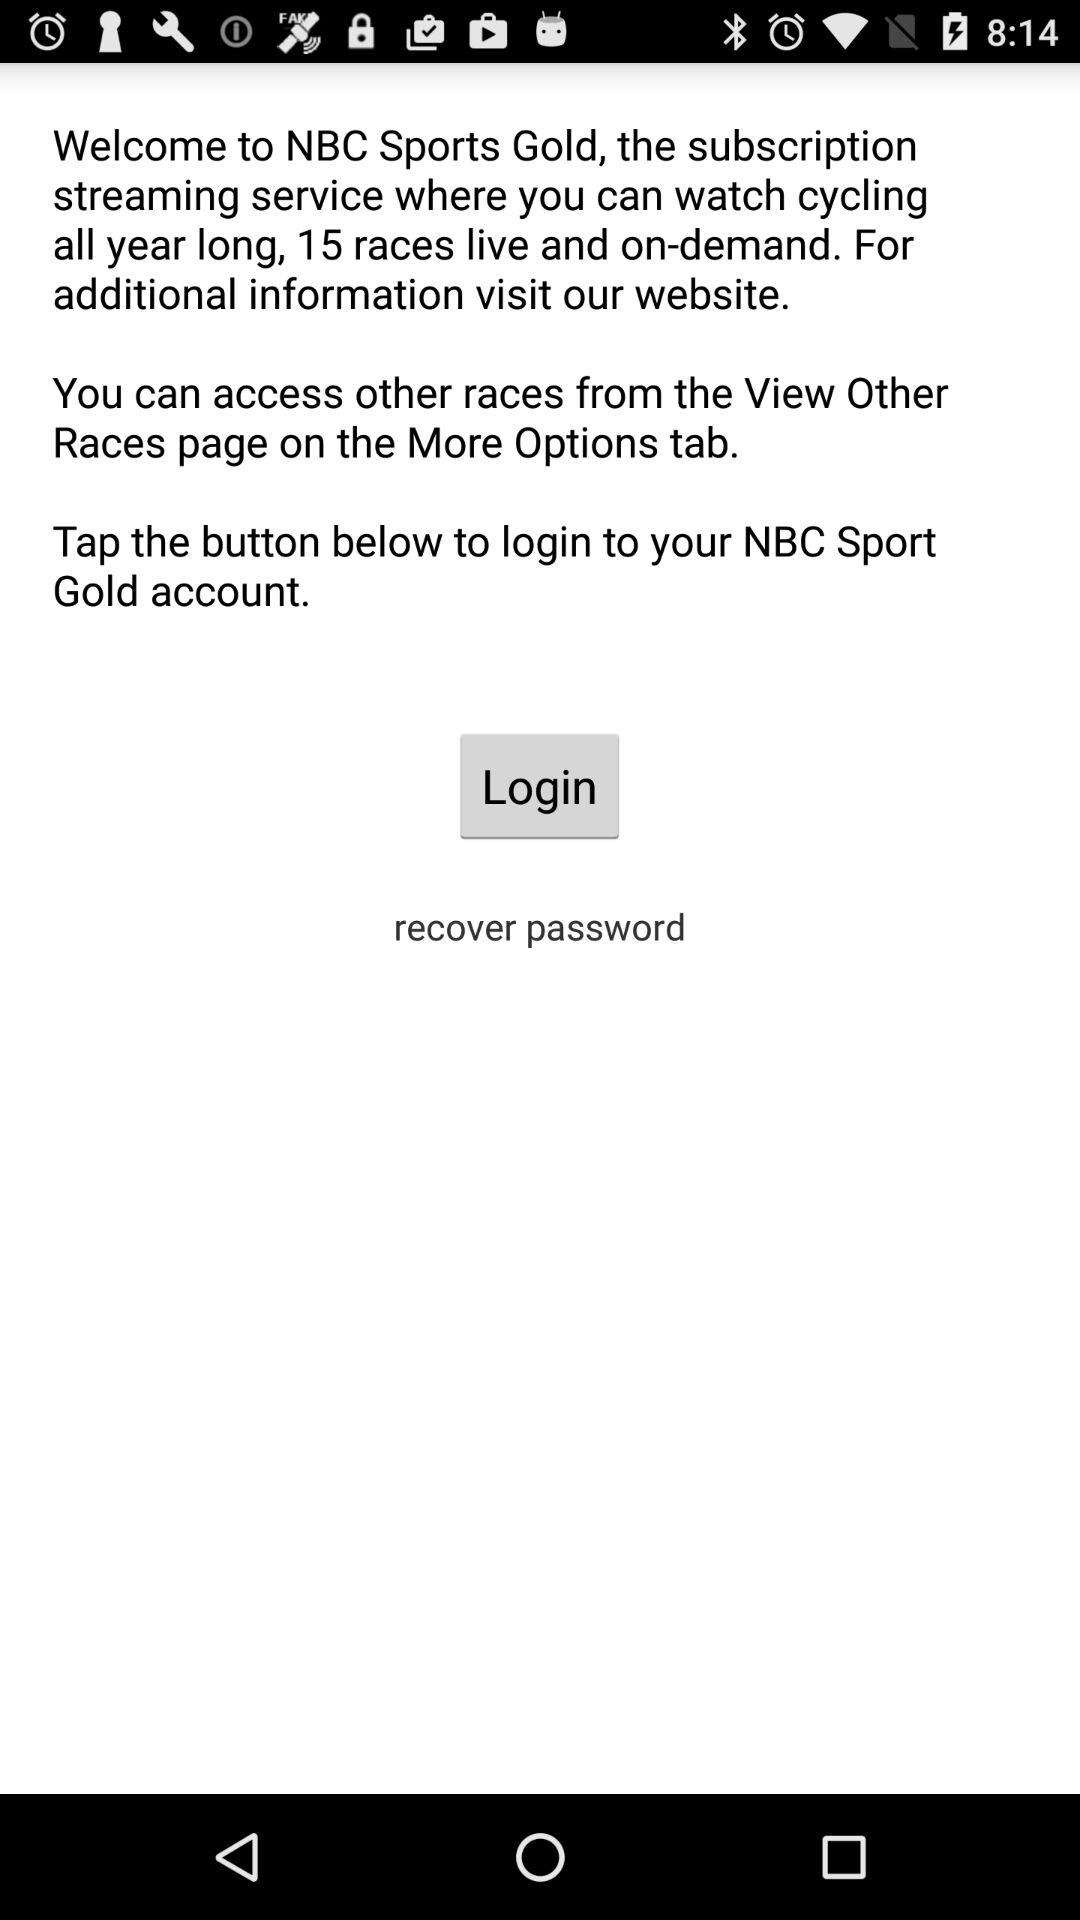How many live races can be watched using the NBC Sports Gold subscription? You can watch 15 live races by using the NBC Sports Gold subscription. 